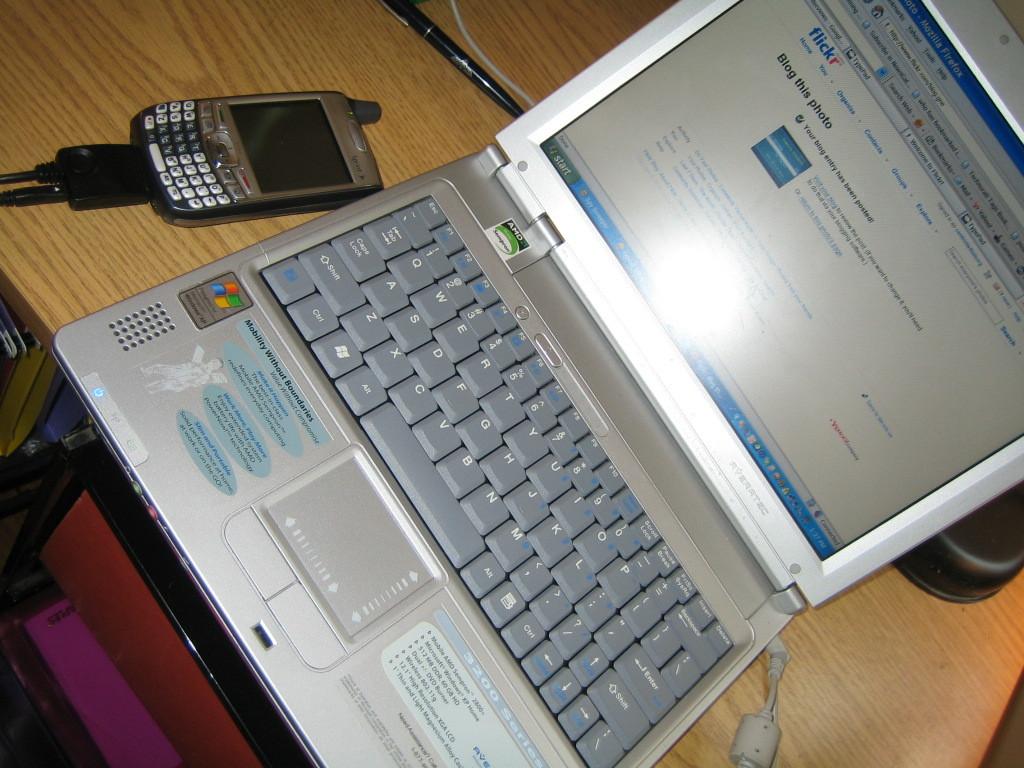What website is the computer on?
Your response must be concise. Flickr. 